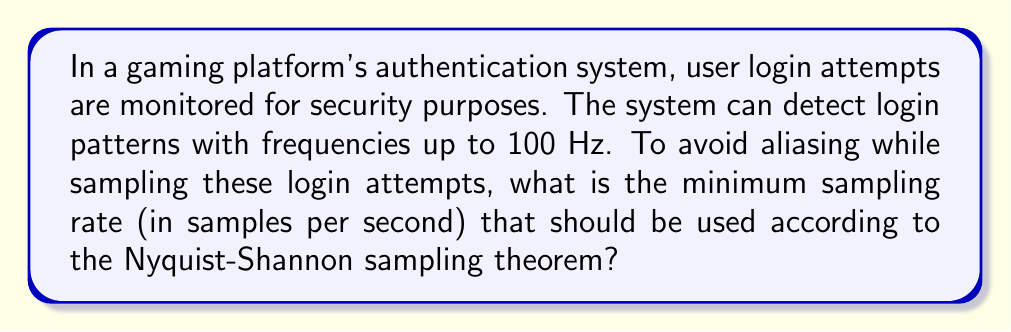Provide a solution to this math problem. To solve this problem, we need to apply the Nyquist-Shannon sampling theorem. This theorem states that to accurately reconstruct a signal, the sampling rate must be at least twice the highest frequency component in the signal.

Given:
- The highest frequency component in the login attempts is 100 Hz.

Step 1: Apply the Nyquist-Shannon sampling theorem.
Minimum sampling rate = 2 × Highest frequency

Step 2: Calculate the minimum sampling rate.
Minimum sampling rate = 2 × 100 Hz = 200 Hz

Therefore, the minimum sampling rate should be 200 samples per second.

This sampling rate ensures that the system can accurately capture and analyze login patterns without aliasing, which is crucial for detecting potential security threats such as brute-force attacks or automated login attempts.
Answer: 200 Hz (samples per second) 